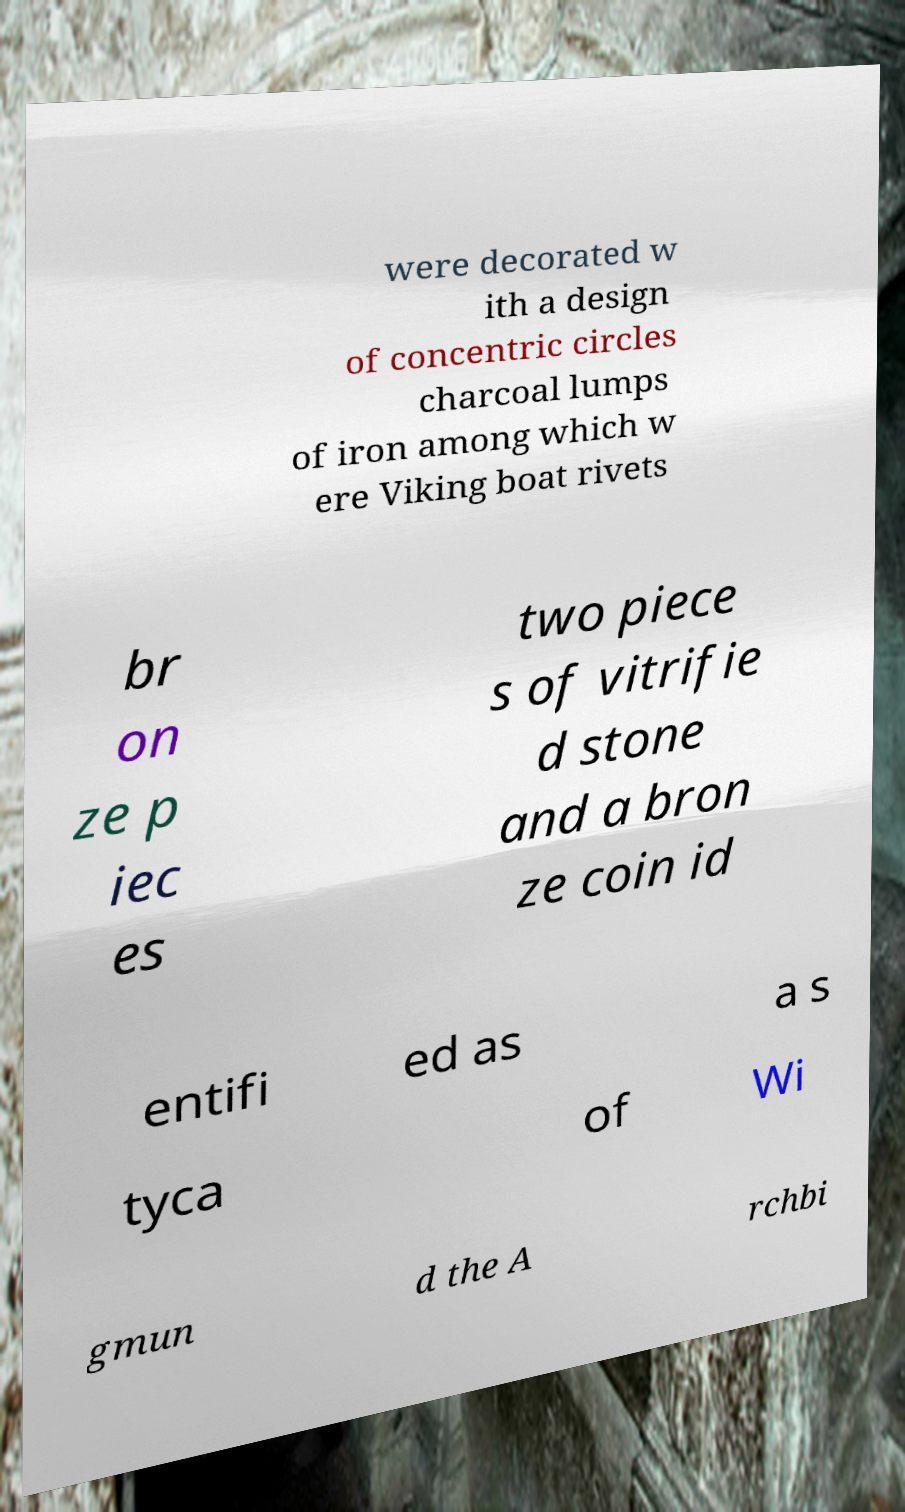Could you assist in decoding the text presented in this image and type it out clearly? were decorated w ith a design of concentric circles charcoal lumps of iron among which w ere Viking boat rivets br on ze p iec es two piece s of vitrifie d stone and a bron ze coin id entifi ed as a s tyca of Wi gmun d the A rchbi 